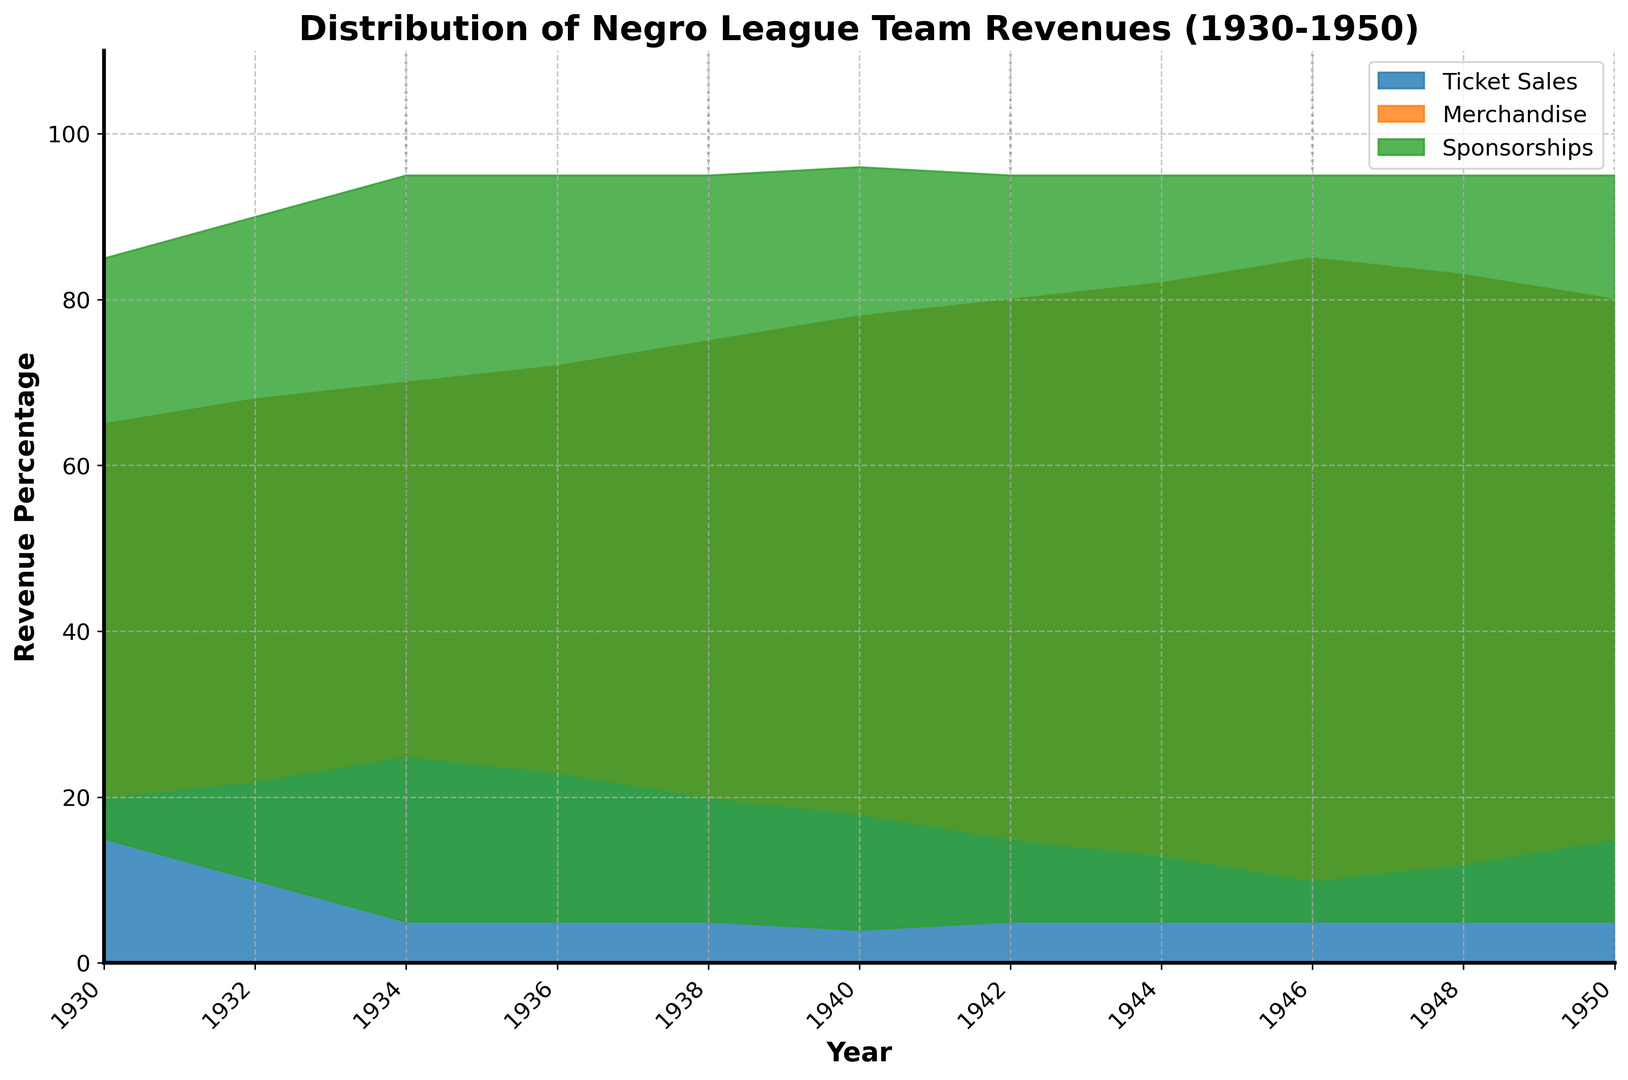What was the revenue difference from ticket sales between 1930 and 1950? To find the revenue difference from ticket sales between 1930 and 1950, subtract the value in 1950 from the value in 1930: 80 - 65 = 15
Answer: 15 In which year did ticket sales revenue reach 85%? Look at the values for ticket sales in the years listed and identify the year where ticket sales were 85%: 1946
Answer: 1946 Investigate the total revenue percentage of merchandise and sponsorships combined in 1944. How much is it? Add the percentage values for merchandise and sponsorships in the year 1944: 13 + 5 = 18
Answer: 18 Which revenue source contributed the least in 1934? Compare the revenue percentages for ticket sales, merchandise, and sponsorships for 1934. Sponsorships have 5%, which is the lowest
Answer: Sponsorships From 1930 to 1950, how did the revenue from merchandise change? Look at the revenue values for merchandise in 1930 and compare it with the value in 1950: 20 in 1930 and 15 in 1950, so it decreased by 5
Answer: Decreased by 5 Which revenue source saw the most significant increase from 1930 to 1950? Ticket sales went from 65% in 1930 to 80% in 1950, an increase of 15%. The other categories either remained the same or decreased
Answer: Ticket sales How did the percentage revenue from sponsorships in 1948 compare to that in 1940? Look at the values for sponsorship revenue in both years: 1948 had 5% and 1940 had 4%. So, 1948 was 1% higher than 1940
Answer: Higher by 1% Which year did merchandise revenue reach its peak, and what was the percentage? Identify the highest percentage value for merchandise across the years and note that it reached 25% in 1934
Answer: 1934, 25% Calculate the mean percentage of ticket sales revenue over the entire period (1930-1950). To get the mean, sum up all the values for ticket sales and divide by the number of observations: (65 + 68 + 70 + 72 + 75 + 78 + 80 + 82 + 85 + 83 + 80)/11 = 889/11 = 80.82
Answer: 80.82 In which year did the combined revenue percentage of merchandise and sponsorships fall to its lowest level, and what was the percentage? Combine the values of merchandise and sponsorships for each year and identify the lowest combined value: 1946 had the lowest combined revenue of 10 + 5 = 15%
Answer: 1946, 15% 